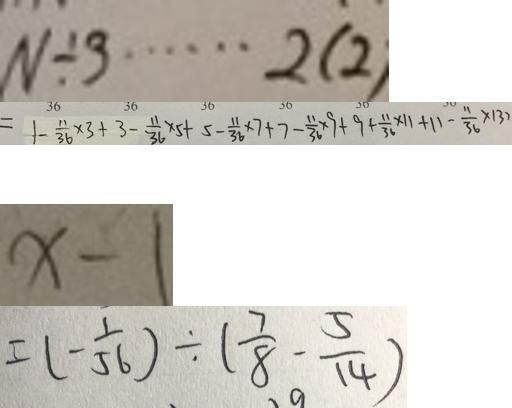Convert formula to latex. <formula><loc_0><loc_0><loc_500><loc_500>N \div 3 \cdots 2 ( 2 ) 
 = 1 - \frac { 1 1 } { 3 6 } \times 3 + 3 - \frac { 1 1 } { 3 6 } \times 5 + 5 - \frac { 1 1 } { 3 6 } \times 7 + 7 - \frac { 1 1 } { 3 6 } \times 9 + 9 + \frac { 1 1 } { 3 6 } \times 1 1 + 1 1 - \frac { 1 1 } { 3 6 } \times 1 3 7 
 x - 1 
 = ( - \frac { 1 } { 5 6 } ) \div ( \frac { 7 } { 8 } - \frac { 5 } { 1 4 } )</formula> 